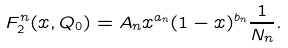<formula> <loc_0><loc_0><loc_500><loc_500>F ^ { n } _ { 2 } ( x , Q _ { 0 } ) = A _ { n } x ^ { a _ { n } } ( 1 - x ) ^ { b _ { n } } \frac { 1 } { N _ { n } } .</formula> 